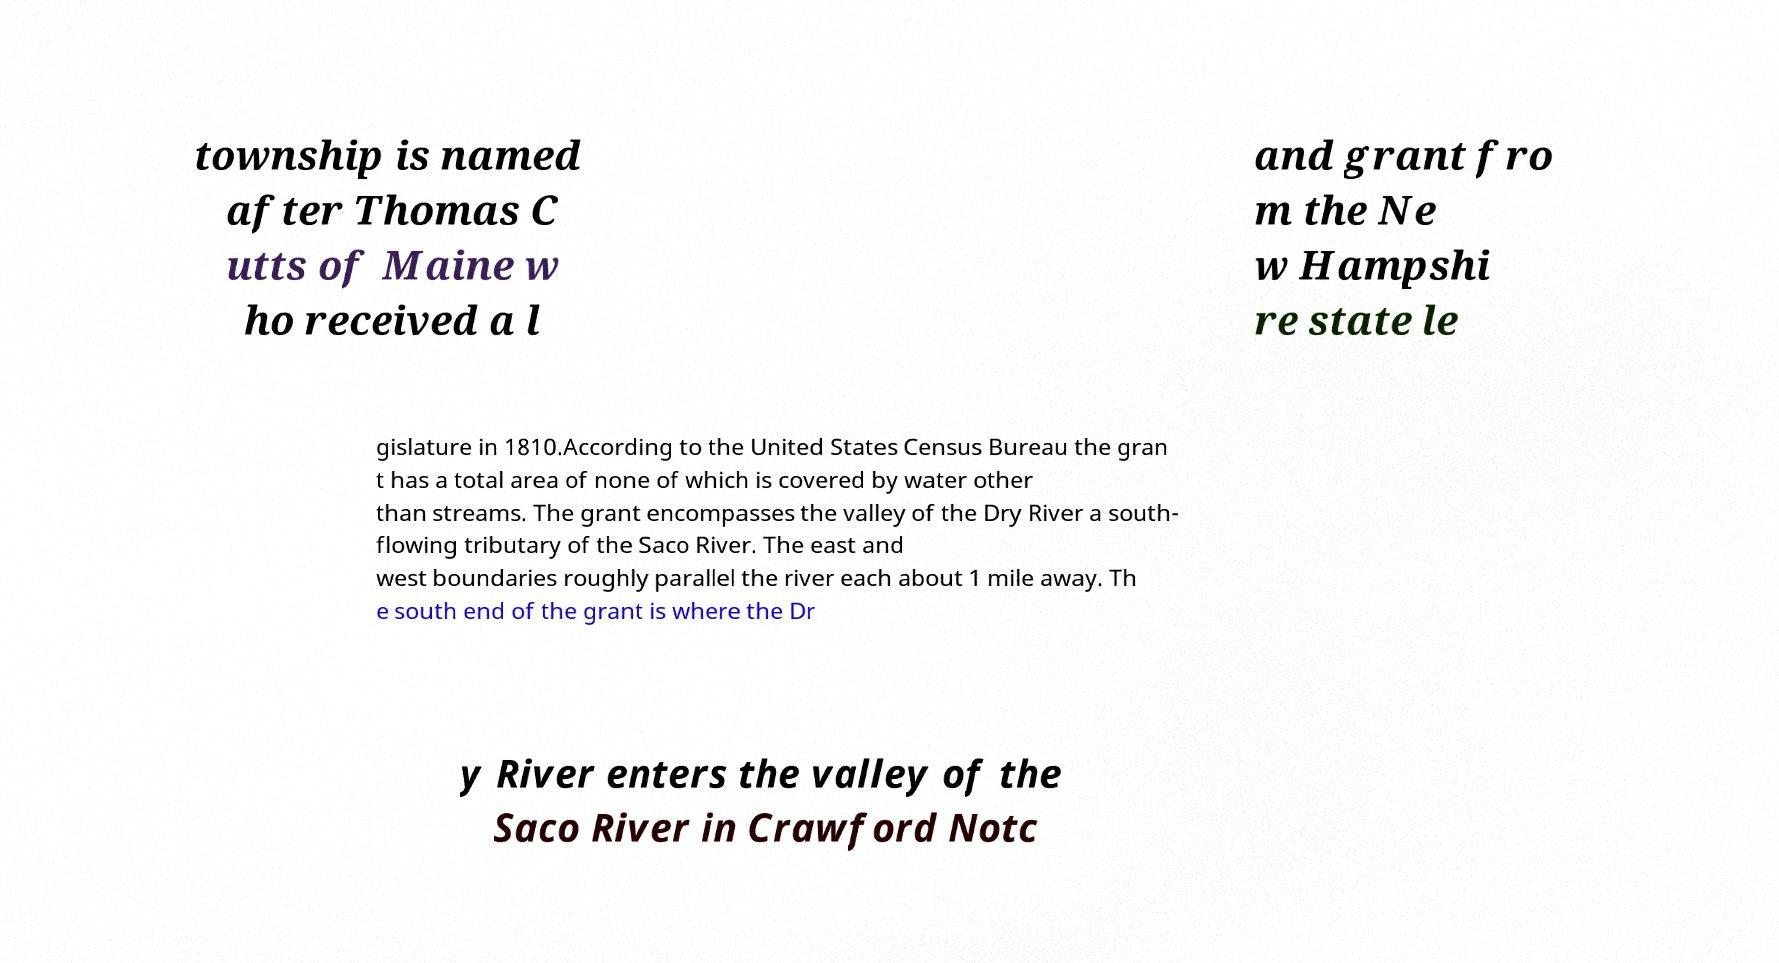There's text embedded in this image that I need extracted. Can you transcribe it verbatim? township is named after Thomas C utts of Maine w ho received a l and grant fro m the Ne w Hampshi re state le gislature in 1810.According to the United States Census Bureau the gran t has a total area of none of which is covered by water other than streams. The grant encompasses the valley of the Dry River a south- flowing tributary of the Saco River. The east and west boundaries roughly parallel the river each about 1 mile away. Th e south end of the grant is where the Dr y River enters the valley of the Saco River in Crawford Notc 